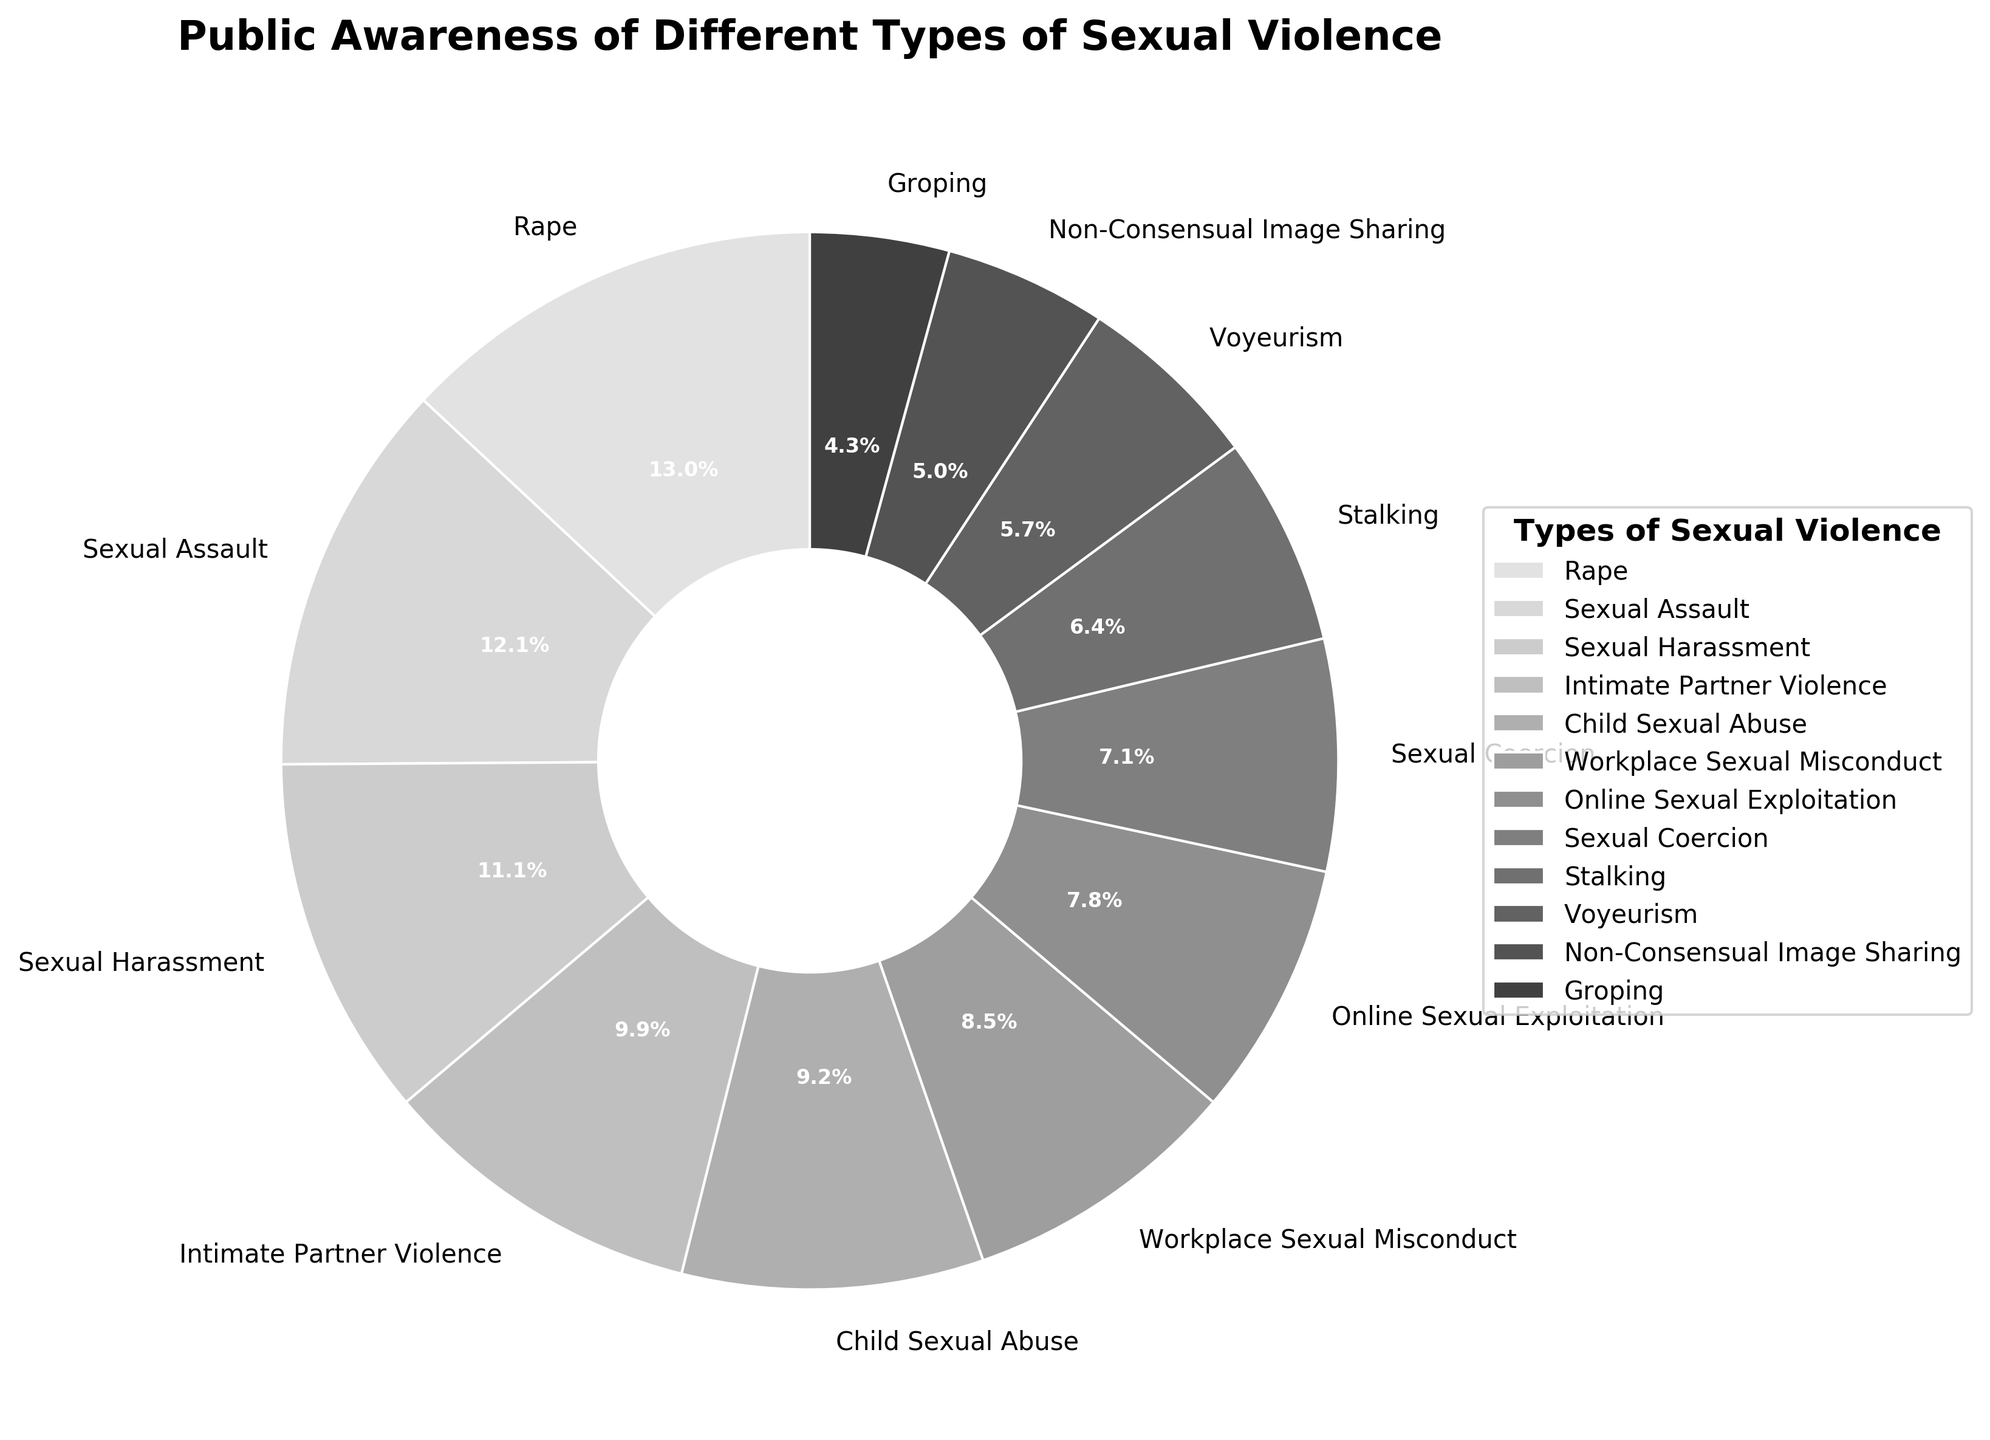What's the most commonly recognized type of sexual violence? Look for the wedge in the pie chart with the largest percentage label. The wedge labeled "Rape" shows 92%, which is the highest.
Answer: Rape What percentage of people are aware of Stalking? Find the wedge labeled "Stalking" in the pie chart and refer to the percentage label on that wedge. It shows 45%.
Answer: 45% Which type of sexual violence has the least public awareness? Identify the smallest wedge in the pie chart. The smallest wedge is labeled "Groping" with 30%.
Answer: Groping What is the difference in public awareness between Sexual Harassment and Online Sexual Exploitation? Find the percentage labels for both categories: Sexual Harassment is at 78%, and Online Sexual Exploitation is at 55%. The difference is calculated as 78% - 55% = 23%.
Answer: 23% How does awareness of Workplace Sexual Misconduct compare to Child Sexual Abuse? Compare the percentage labels on both wedges: Workplace Sexual Misconduct is 60%, and Child Sexual Abuse is 65%. Since 60% < 65%, awareness of Workplace Sexual Misconduct is lower.
Answer: Lower What is the cumulative public awareness for Rape, Sexual Assault, and Sexual Harassment? Find the percentage labels for these three categories: Rape (92%), Sexual Assault (85%), and Sexual Harassment (78%). Sum them up: 92% + 85% + 78% = 255%.
Answer: 255% Which two types of sexual violence are closest in public awareness percentage? Look for wedges with percentage labels that are closest in value. "Non-Consensual Image Sharing" (35%) and "Groping" (30%) have the smallest difference of 5%.
Answer: Non-Consensual Image Sharing and Groping What's the median value of public awareness across all types of sexual violence? List the percentage labels in ascending order: 30%, 35%, 40%, 45%, 50%, 55%, 60%, 65%, 70%, 78%, 85%, 92%. The middle value (median) in this list is 60%.
Answer: 60% 